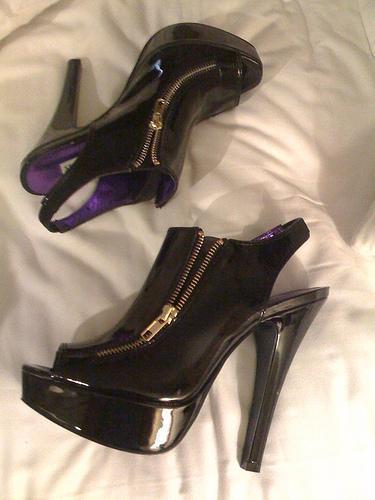How many beds are in the picture?
Give a very brief answer. 1. How many motorcycles are here?
Give a very brief answer. 0. 